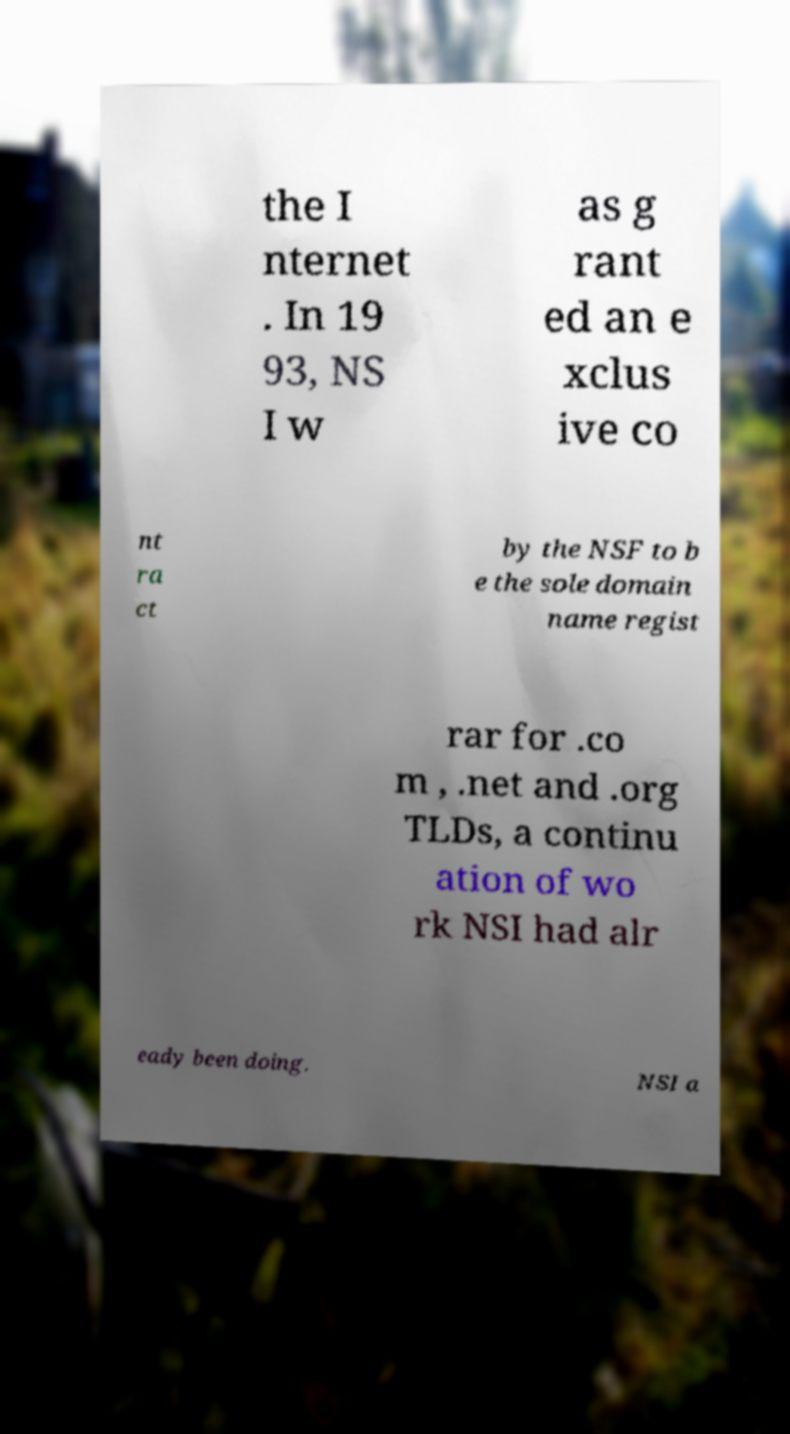Please read and relay the text visible in this image. What does it say? the I nternet . In 19 93, NS I w as g rant ed an e xclus ive co nt ra ct by the NSF to b e the sole domain name regist rar for .co m , .net and .org TLDs, a continu ation of wo rk NSI had alr eady been doing. NSI a 